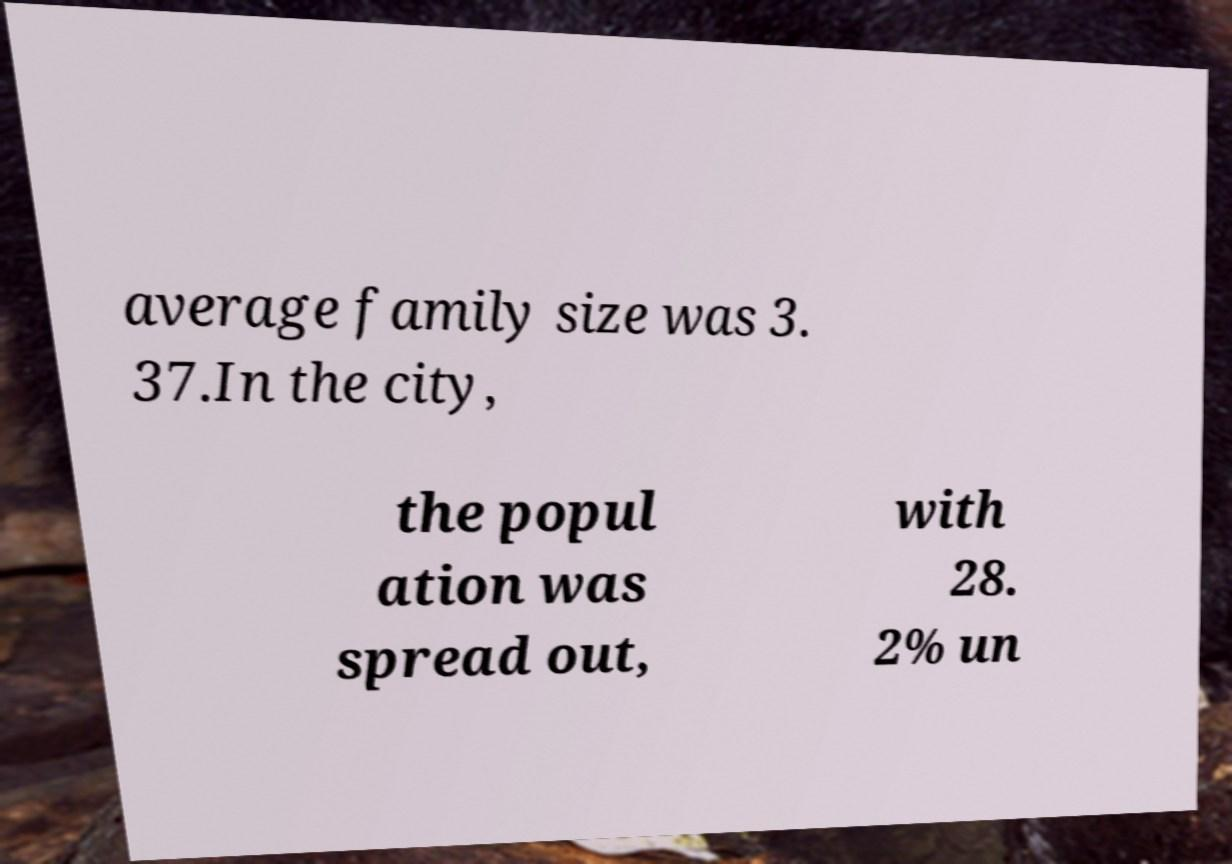Could you assist in decoding the text presented in this image and type it out clearly? average family size was 3. 37.In the city, the popul ation was spread out, with 28. 2% un 